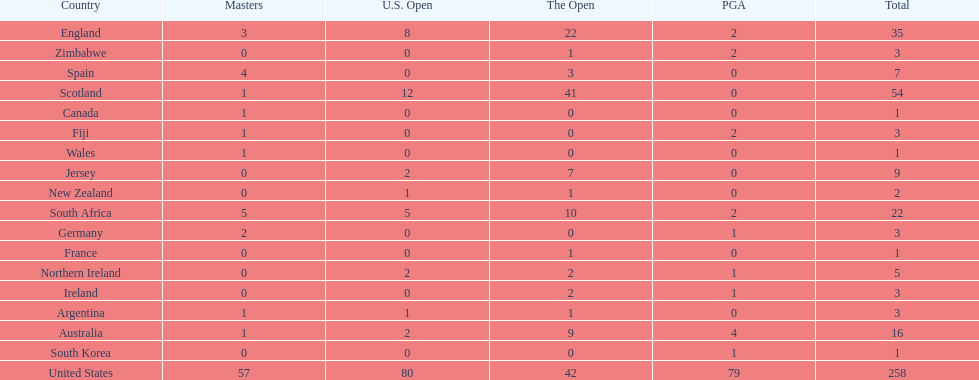What are the number of pga winning golfers that zimbabwe has? 2. 